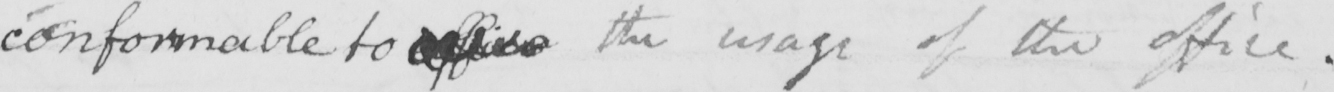Please provide the text content of this handwritten line. conformable to office the usage of the office . 